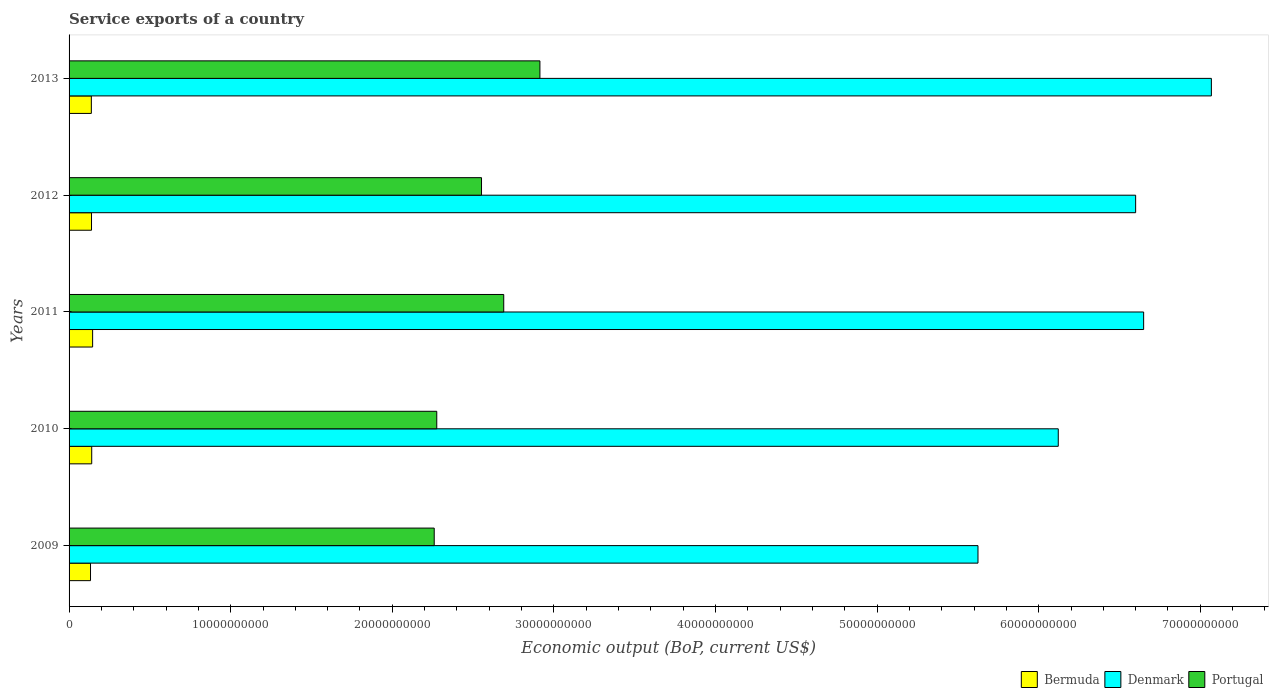Are the number of bars on each tick of the Y-axis equal?
Offer a terse response. Yes. In how many cases, is the number of bars for a given year not equal to the number of legend labels?
Provide a succinct answer. 0. What is the service exports in Bermuda in 2012?
Offer a very short reply. 1.39e+09. Across all years, what is the maximum service exports in Portugal?
Ensure brevity in your answer.  2.91e+1. Across all years, what is the minimum service exports in Portugal?
Your response must be concise. 2.26e+1. In which year was the service exports in Portugal maximum?
Your response must be concise. 2013. In which year was the service exports in Denmark minimum?
Your answer should be very brief. 2009. What is the total service exports in Bermuda in the graph?
Keep it short and to the point. 6.95e+09. What is the difference between the service exports in Denmark in 2009 and that in 2012?
Give a very brief answer. -9.76e+09. What is the difference between the service exports in Portugal in 2011 and the service exports in Bermuda in 2013?
Make the answer very short. 2.55e+1. What is the average service exports in Denmark per year?
Offer a terse response. 6.41e+1. In the year 2010, what is the difference between the service exports in Denmark and service exports in Portugal?
Give a very brief answer. 3.85e+1. In how many years, is the service exports in Denmark greater than 44000000000 US$?
Give a very brief answer. 5. What is the ratio of the service exports in Bermuda in 2011 to that in 2013?
Give a very brief answer. 1.06. Is the difference between the service exports in Denmark in 2009 and 2012 greater than the difference between the service exports in Portugal in 2009 and 2012?
Ensure brevity in your answer.  No. What is the difference between the highest and the second highest service exports in Portugal?
Ensure brevity in your answer.  2.24e+09. What is the difference between the highest and the lowest service exports in Denmark?
Your response must be concise. 1.44e+1. In how many years, is the service exports in Denmark greater than the average service exports in Denmark taken over all years?
Offer a terse response. 3. What does the 1st bar from the top in 2012 represents?
Your response must be concise. Portugal. Is it the case that in every year, the sum of the service exports in Portugal and service exports in Denmark is greater than the service exports in Bermuda?
Make the answer very short. Yes. How many bars are there?
Your answer should be compact. 15. Are all the bars in the graph horizontal?
Provide a succinct answer. Yes. How many years are there in the graph?
Keep it short and to the point. 5. What is the difference between two consecutive major ticks on the X-axis?
Give a very brief answer. 1.00e+1. Are the values on the major ticks of X-axis written in scientific E-notation?
Offer a terse response. No. Where does the legend appear in the graph?
Your answer should be compact. Bottom right. What is the title of the graph?
Your answer should be compact. Service exports of a country. Does "East Asia (all income levels)" appear as one of the legend labels in the graph?
Ensure brevity in your answer.  No. What is the label or title of the X-axis?
Give a very brief answer. Economic output (BoP, current US$). What is the label or title of the Y-axis?
Your response must be concise. Years. What is the Economic output (BoP, current US$) of Bermuda in 2009?
Provide a short and direct response. 1.33e+09. What is the Economic output (BoP, current US$) in Denmark in 2009?
Offer a very short reply. 5.62e+1. What is the Economic output (BoP, current US$) in Portugal in 2009?
Your answer should be very brief. 2.26e+1. What is the Economic output (BoP, current US$) in Bermuda in 2010?
Your response must be concise. 1.40e+09. What is the Economic output (BoP, current US$) in Denmark in 2010?
Your response must be concise. 6.12e+1. What is the Economic output (BoP, current US$) in Portugal in 2010?
Offer a very short reply. 2.28e+1. What is the Economic output (BoP, current US$) in Bermuda in 2011?
Offer a very short reply. 1.46e+09. What is the Economic output (BoP, current US$) in Denmark in 2011?
Provide a short and direct response. 6.65e+1. What is the Economic output (BoP, current US$) in Portugal in 2011?
Offer a terse response. 2.69e+1. What is the Economic output (BoP, current US$) in Bermuda in 2012?
Offer a very short reply. 1.39e+09. What is the Economic output (BoP, current US$) of Denmark in 2012?
Your response must be concise. 6.60e+1. What is the Economic output (BoP, current US$) of Portugal in 2012?
Keep it short and to the point. 2.55e+1. What is the Economic output (BoP, current US$) of Bermuda in 2013?
Your answer should be very brief. 1.38e+09. What is the Economic output (BoP, current US$) in Denmark in 2013?
Provide a short and direct response. 7.07e+1. What is the Economic output (BoP, current US$) of Portugal in 2013?
Give a very brief answer. 2.91e+1. Across all years, what is the maximum Economic output (BoP, current US$) of Bermuda?
Keep it short and to the point. 1.46e+09. Across all years, what is the maximum Economic output (BoP, current US$) in Denmark?
Provide a succinct answer. 7.07e+1. Across all years, what is the maximum Economic output (BoP, current US$) of Portugal?
Give a very brief answer. 2.91e+1. Across all years, what is the minimum Economic output (BoP, current US$) of Bermuda?
Keep it short and to the point. 1.33e+09. Across all years, what is the minimum Economic output (BoP, current US$) of Denmark?
Your answer should be very brief. 5.62e+1. Across all years, what is the minimum Economic output (BoP, current US$) of Portugal?
Make the answer very short. 2.26e+1. What is the total Economic output (BoP, current US$) in Bermuda in the graph?
Offer a terse response. 6.95e+09. What is the total Economic output (BoP, current US$) of Denmark in the graph?
Ensure brevity in your answer.  3.21e+11. What is the total Economic output (BoP, current US$) in Portugal in the graph?
Make the answer very short. 1.27e+11. What is the difference between the Economic output (BoP, current US$) of Bermuda in 2009 and that in 2010?
Offer a very short reply. -7.46e+07. What is the difference between the Economic output (BoP, current US$) in Denmark in 2009 and that in 2010?
Offer a terse response. -4.97e+09. What is the difference between the Economic output (BoP, current US$) of Portugal in 2009 and that in 2010?
Your answer should be very brief. -1.58e+08. What is the difference between the Economic output (BoP, current US$) in Bermuda in 2009 and that in 2011?
Keep it short and to the point. -1.31e+08. What is the difference between the Economic output (BoP, current US$) in Denmark in 2009 and that in 2011?
Your response must be concise. -1.03e+1. What is the difference between the Economic output (BoP, current US$) of Portugal in 2009 and that in 2011?
Your answer should be compact. -4.30e+09. What is the difference between the Economic output (BoP, current US$) in Bermuda in 2009 and that in 2012?
Give a very brief answer. -6.20e+07. What is the difference between the Economic output (BoP, current US$) in Denmark in 2009 and that in 2012?
Your answer should be very brief. -9.76e+09. What is the difference between the Economic output (BoP, current US$) in Portugal in 2009 and that in 2012?
Make the answer very short. -2.93e+09. What is the difference between the Economic output (BoP, current US$) in Bermuda in 2009 and that in 2013?
Your answer should be very brief. -5.16e+07. What is the difference between the Economic output (BoP, current US$) of Denmark in 2009 and that in 2013?
Offer a very short reply. -1.44e+1. What is the difference between the Economic output (BoP, current US$) in Portugal in 2009 and that in 2013?
Ensure brevity in your answer.  -6.54e+09. What is the difference between the Economic output (BoP, current US$) in Bermuda in 2010 and that in 2011?
Make the answer very short. -5.64e+07. What is the difference between the Economic output (BoP, current US$) of Denmark in 2010 and that in 2011?
Provide a succinct answer. -5.28e+09. What is the difference between the Economic output (BoP, current US$) in Portugal in 2010 and that in 2011?
Give a very brief answer. -4.14e+09. What is the difference between the Economic output (BoP, current US$) in Bermuda in 2010 and that in 2012?
Provide a short and direct response. 1.26e+07. What is the difference between the Economic output (BoP, current US$) in Denmark in 2010 and that in 2012?
Offer a very short reply. -4.79e+09. What is the difference between the Economic output (BoP, current US$) of Portugal in 2010 and that in 2012?
Provide a succinct answer. -2.77e+09. What is the difference between the Economic output (BoP, current US$) of Bermuda in 2010 and that in 2013?
Your response must be concise. 2.30e+07. What is the difference between the Economic output (BoP, current US$) of Denmark in 2010 and that in 2013?
Keep it short and to the point. -9.47e+09. What is the difference between the Economic output (BoP, current US$) in Portugal in 2010 and that in 2013?
Give a very brief answer. -6.38e+09. What is the difference between the Economic output (BoP, current US$) of Bermuda in 2011 and that in 2012?
Your answer should be very brief. 6.91e+07. What is the difference between the Economic output (BoP, current US$) in Denmark in 2011 and that in 2012?
Your answer should be very brief. 4.95e+08. What is the difference between the Economic output (BoP, current US$) of Portugal in 2011 and that in 2012?
Offer a terse response. 1.37e+09. What is the difference between the Economic output (BoP, current US$) of Bermuda in 2011 and that in 2013?
Give a very brief answer. 7.95e+07. What is the difference between the Economic output (BoP, current US$) in Denmark in 2011 and that in 2013?
Provide a succinct answer. -4.19e+09. What is the difference between the Economic output (BoP, current US$) in Portugal in 2011 and that in 2013?
Make the answer very short. -2.24e+09. What is the difference between the Economic output (BoP, current US$) in Bermuda in 2012 and that in 2013?
Offer a very short reply. 1.04e+07. What is the difference between the Economic output (BoP, current US$) of Denmark in 2012 and that in 2013?
Keep it short and to the point. -4.69e+09. What is the difference between the Economic output (BoP, current US$) in Portugal in 2012 and that in 2013?
Your response must be concise. -3.61e+09. What is the difference between the Economic output (BoP, current US$) of Bermuda in 2009 and the Economic output (BoP, current US$) of Denmark in 2010?
Keep it short and to the point. -5.99e+1. What is the difference between the Economic output (BoP, current US$) of Bermuda in 2009 and the Economic output (BoP, current US$) of Portugal in 2010?
Your response must be concise. -2.14e+1. What is the difference between the Economic output (BoP, current US$) in Denmark in 2009 and the Economic output (BoP, current US$) in Portugal in 2010?
Provide a succinct answer. 3.35e+1. What is the difference between the Economic output (BoP, current US$) of Bermuda in 2009 and the Economic output (BoP, current US$) of Denmark in 2011?
Your response must be concise. -6.52e+1. What is the difference between the Economic output (BoP, current US$) of Bermuda in 2009 and the Economic output (BoP, current US$) of Portugal in 2011?
Provide a short and direct response. -2.56e+1. What is the difference between the Economic output (BoP, current US$) in Denmark in 2009 and the Economic output (BoP, current US$) in Portugal in 2011?
Keep it short and to the point. 2.93e+1. What is the difference between the Economic output (BoP, current US$) of Bermuda in 2009 and the Economic output (BoP, current US$) of Denmark in 2012?
Your answer should be very brief. -6.47e+1. What is the difference between the Economic output (BoP, current US$) in Bermuda in 2009 and the Economic output (BoP, current US$) in Portugal in 2012?
Your answer should be very brief. -2.42e+1. What is the difference between the Economic output (BoP, current US$) of Denmark in 2009 and the Economic output (BoP, current US$) of Portugal in 2012?
Your response must be concise. 3.07e+1. What is the difference between the Economic output (BoP, current US$) of Bermuda in 2009 and the Economic output (BoP, current US$) of Denmark in 2013?
Your response must be concise. -6.94e+1. What is the difference between the Economic output (BoP, current US$) in Bermuda in 2009 and the Economic output (BoP, current US$) in Portugal in 2013?
Make the answer very short. -2.78e+1. What is the difference between the Economic output (BoP, current US$) in Denmark in 2009 and the Economic output (BoP, current US$) in Portugal in 2013?
Ensure brevity in your answer.  2.71e+1. What is the difference between the Economic output (BoP, current US$) in Bermuda in 2010 and the Economic output (BoP, current US$) in Denmark in 2011?
Your response must be concise. -6.51e+1. What is the difference between the Economic output (BoP, current US$) in Bermuda in 2010 and the Economic output (BoP, current US$) in Portugal in 2011?
Make the answer very short. -2.55e+1. What is the difference between the Economic output (BoP, current US$) in Denmark in 2010 and the Economic output (BoP, current US$) in Portugal in 2011?
Your answer should be compact. 3.43e+1. What is the difference between the Economic output (BoP, current US$) of Bermuda in 2010 and the Economic output (BoP, current US$) of Denmark in 2012?
Your answer should be very brief. -6.46e+1. What is the difference between the Economic output (BoP, current US$) of Bermuda in 2010 and the Economic output (BoP, current US$) of Portugal in 2012?
Keep it short and to the point. -2.41e+1. What is the difference between the Economic output (BoP, current US$) in Denmark in 2010 and the Economic output (BoP, current US$) in Portugal in 2012?
Offer a very short reply. 3.57e+1. What is the difference between the Economic output (BoP, current US$) in Bermuda in 2010 and the Economic output (BoP, current US$) in Denmark in 2013?
Provide a succinct answer. -6.93e+1. What is the difference between the Economic output (BoP, current US$) in Bermuda in 2010 and the Economic output (BoP, current US$) in Portugal in 2013?
Your answer should be compact. -2.77e+1. What is the difference between the Economic output (BoP, current US$) in Denmark in 2010 and the Economic output (BoP, current US$) in Portugal in 2013?
Your answer should be compact. 3.21e+1. What is the difference between the Economic output (BoP, current US$) in Bermuda in 2011 and the Economic output (BoP, current US$) in Denmark in 2012?
Your answer should be very brief. -6.45e+1. What is the difference between the Economic output (BoP, current US$) in Bermuda in 2011 and the Economic output (BoP, current US$) in Portugal in 2012?
Ensure brevity in your answer.  -2.41e+1. What is the difference between the Economic output (BoP, current US$) of Denmark in 2011 and the Economic output (BoP, current US$) of Portugal in 2012?
Your response must be concise. 4.10e+1. What is the difference between the Economic output (BoP, current US$) of Bermuda in 2011 and the Economic output (BoP, current US$) of Denmark in 2013?
Your answer should be very brief. -6.92e+1. What is the difference between the Economic output (BoP, current US$) in Bermuda in 2011 and the Economic output (BoP, current US$) in Portugal in 2013?
Give a very brief answer. -2.77e+1. What is the difference between the Economic output (BoP, current US$) in Denmark in 2011 and the Economic output (BoP, current US$) in Portugal in 2013?
Make the answer very short. 3.74e+1. What is the difference between the Economic output (BoP, current US$) of Bermuda in 2012 and the Economic output (BoP, current US$) of Denmark in 2013?
Offer a terse response. -6.93e+1. What is the difference between the Economic output (BoP, current US$) in Bermuda in 2012 and the Economic output (BoP, current US$) in Portugal in 2013?
Make the answer very short. -2.77e+1. What is the difference between the Economic output (BoP, current US$) of Denmark in 2012 and the Economic output (BoP, current US$) of Portugal in 2013?
Ensure brevity in your answer.  3.69e+1. What is the average Economic output (BoP, current US$) of Bermuda per year?
Make the answer very short. 1.39e+09. What is the average Economic output (BoP, current US$) in Denmark per year?
Make the answer very short. 6.41e+1. What is the average Economic output (BoP, current US$) in Portugal per year?
Ensure brevity in your answer.  2.54e+1. In the year 2009, what is the difference between the Economic output (BoP, current US$) of Bermuda and Economic output (BoP, current US$) of Denmark?
Provide a short and direct response. -5.49e+1. In the year 2009, what is the difference between the Economic output (BoP, current US$) of Bermuda and Economic output (BoP, current US$) of Portugal?
Keep it short and to the point. -2.13e+1. In the year 2009, what is the difference between the Economic output (BoP, current US$) of Denmark and Economic output (BoP, current US$) of Portugal?
Your response must be concise. 3.36e+1. In the year 2010, what is the difference between the Economic output (BoP, current US$) in Bermuda and Economic output (BoP, current US$) in Denmark?
Make the answer very short. -5.98e+1. In the year 2010, what is the difference between the Economic output (BoP, current US$) of Bermuda and Economic output (BoP, current US$) of Portugal?
Offer a very short reply. -2.14e+1. In the year 2010, what is the difference between the Economic output (BoP, current US$) in Denmark and Economic output (BoP, current US$) in Portugal?
Your response must be concise. 3.85e+1. In the year 2011, what is the difference between the Economic output (BoP, current US$) in Bermuda and Economic output (BoP, current US$) in Denmark?
Provide a short and direct response. -6.50e+1. In the year 2011, what is the difference between the Economic output (BoP, current US$) in Bermuda and Economic output (BoP, current US$) in Portugal?
Your answer should be very brief. -2.54e+1. In the year 2011, what is the difference between the Economic output (BoP, current US$) in Denmark and Economic output (BoP, current US$) in Portugal?
Your response must be concise. 3.96e+1. In the year 2012, what is the difference between the Economic output (BoP, current US$) of Bermuda and Economic output (BoP, current US$) of Denmark?
Your response must be concise. -6.46e+1. In the year 2012, what is the difference between the Economic output (BoP, current US$) of Bermuda and Economic output (BoP, current US$) of Portugal?
Make the answer very short. -2.41e+1. In the year 2012, what is the difference between the Economic output (BoP, current US$) of Denmark and Economic output (BoP, current US$) of Portugal?
Make the answer very short. 4.05e+1. In the year 2013, what is the difference between the Economic output (BoP, current US$) in Bermuda and Economic output (BoP, current US$) in Denmark?
Your response must be concise. -6.93e+1. In the year 2013, what is the difference between the Economic output (BoP, current US$) of Bermuda and Economic output (BoP, current US$) of Portugal?
Give a very brief answer. -2.78e+1. In the year 2013, what is the difference between the Economic output (BoP, current US$) in Denmark and Economic output (BoP, current US$) in Portugal?
Provide a succinct answer. 4.15e+1. What is the ratio of the Economic output (BoP, current US$) in Bermuda in 2009 to that in 2010?
Make the answer very short. 0.95. What is the ratio of the Economic output (BoP, current US$) in Denmark in 2009 to that in 2010?
Your answer should be very brief. 0.92. What is the ratio of the Economic output (BoP, current US$) in Bermuda in 2009 to that in 2011?
Your response must be concise. 0.91. What is the ratio of the Economic output (BoP, current US$) of Denmark in 2009 to that in 2011?
Offer a very short reply. 0.85. What is the ratio of the Economic output (BoP, current US$) of Portugal in 2009 to that in 2011?
Offer a terse response. 0.84. What is the ratio of the Economic output (BoP, current US$) in Bermuda in 2009 to that in 2012?
Keep it short and to the point. 0.96. What is the ratio of the Economic output (BoP, current US$) in Denmark in 2009 to that in 2012?
Keep it short and to the point. 0.85. What is the ratio of the Economic output (BoP, current US$) of Portugal in 2009 to that in 2012?
Offer a terse response. 0.89. What is the ratio of the Economic output (BoP, current US$) of Bermuda in 2009 to that in 2013?
Offer a very short reply. 0.96. What is the ratio of the Economic output (BoP, current US$) of Denmark in 2009 to that in 2013?
Offer a very short reply. 0.8. What is the ratio of the Economic output (BoP, current US$) of Portugal in 2009 to that in 2013?
Your response must be concise. 0.78. What is the ratio of the Economic output (BoP, current US$) of Bermuda in 2010 to that in 2011?
Offer a terse response. 0.96. What is the ratio of the Economic output (BoP, current US$) in Denmark in 2010 to that in 2011?
Ensure brevity in your answer.  0.92. What is the ratio of the Economic output (BoP, current US$) in Portugal in 2010 to that in 2011?
Make the answer very short. 0.85. What is the ratio of the Economic output (BoP, current US$) of Bermuda in 2010 to that in 2012?
Keep it short and to the point. 1.01. What is the ratio of the Economic output (BoP, current US$) in Denmark in 2010 to that in 2012?
Your response must be concise. 0.93. What is the ratio of the Economic output (BoP, current US$) of Portugal in 2010 to that in 2012?
Give a very brief answer. 0.89. What is the ratio of the Economic output (BoP, current US$) of Bermuda in 2010 to that in 2013?
Your response must be concise. 1.02. What is the ratio of the Economic output (BoP, current US$) of Denmark in 2010 to that in 2013?
Offer a terse response. 0.87. What is the ratio of the Economic output (BoP, current US$) of Portugal in 2010 to that in 2013?
Give a very brief answer. 0.78. What is the ratio of the Economic output (BoP, current US$) of Bermuda in 2011 to that in 2012?
Your answer should be very brief. 1.05. What is the ratio of the Economic output (BoP, current US$) of Denmark in 2011 to that in 2012?
Your answer should be very brief. 1.01. What is the ratio of the Economic output (BoP, current US$) in Portugal in 2011 to that in 2012?
Offer a very short reply. 1.05. What is the ratio of the Economic output (BoP, current US$) of Bermuda in 2011 to that in 2013?
Make the answer very short. 1.06. What is the ratio of the Economic output (BoP, current US$) of Denmark in 2011 to that in 2013?
Provide a succinct answer. 0.94. What is the ratio of the Economic output (BoP, current US$) in Portugal in 2011 to that in 2013?
Your response must be concise. 0.92. What is the ratio of the Economic output (BoP, current US$) in Bermuda in 2012 to that in 2013?
Your answer should be compact. 1.01. What is the ratio of the Economic output (BoP, current US$) in Denmark in 2012 to that in 2013?
Make the answer very short. 0.93. What is the ratio of the Economic output (BoP, current US$) in Portugal in 2012 to that in 2013?
Your answer should be compact. 0.88. What is the difference between the highest and the second highest Economic output (BoP, current US$) of Bermuda?
Give a very brief answer. 5.64e+07. What is the difference between the highest and the second highest Economic output (BoP, current US$) in Denmark?
Make the answer very short. 4.19e+09. What is the difference between the highest and the second highest Economic output (BoP, current US$) in Portugal?
Provide a short and direct response. 2.24e+09. What is the difference between the highest and the lowest Economic output (BoP, current US$) in Bermuda?
Your response must be concise. 1.31e+08. What is the difference between the highest and the lowest Economic output (BoP, current US$) of Denmark?
Provide a short and direct response. 1.44e+1. What is the difference between the highest and the lowest Economic output (BoP, current US$) in Portugal?
Your answer should be very brief. 6.54e+09. 